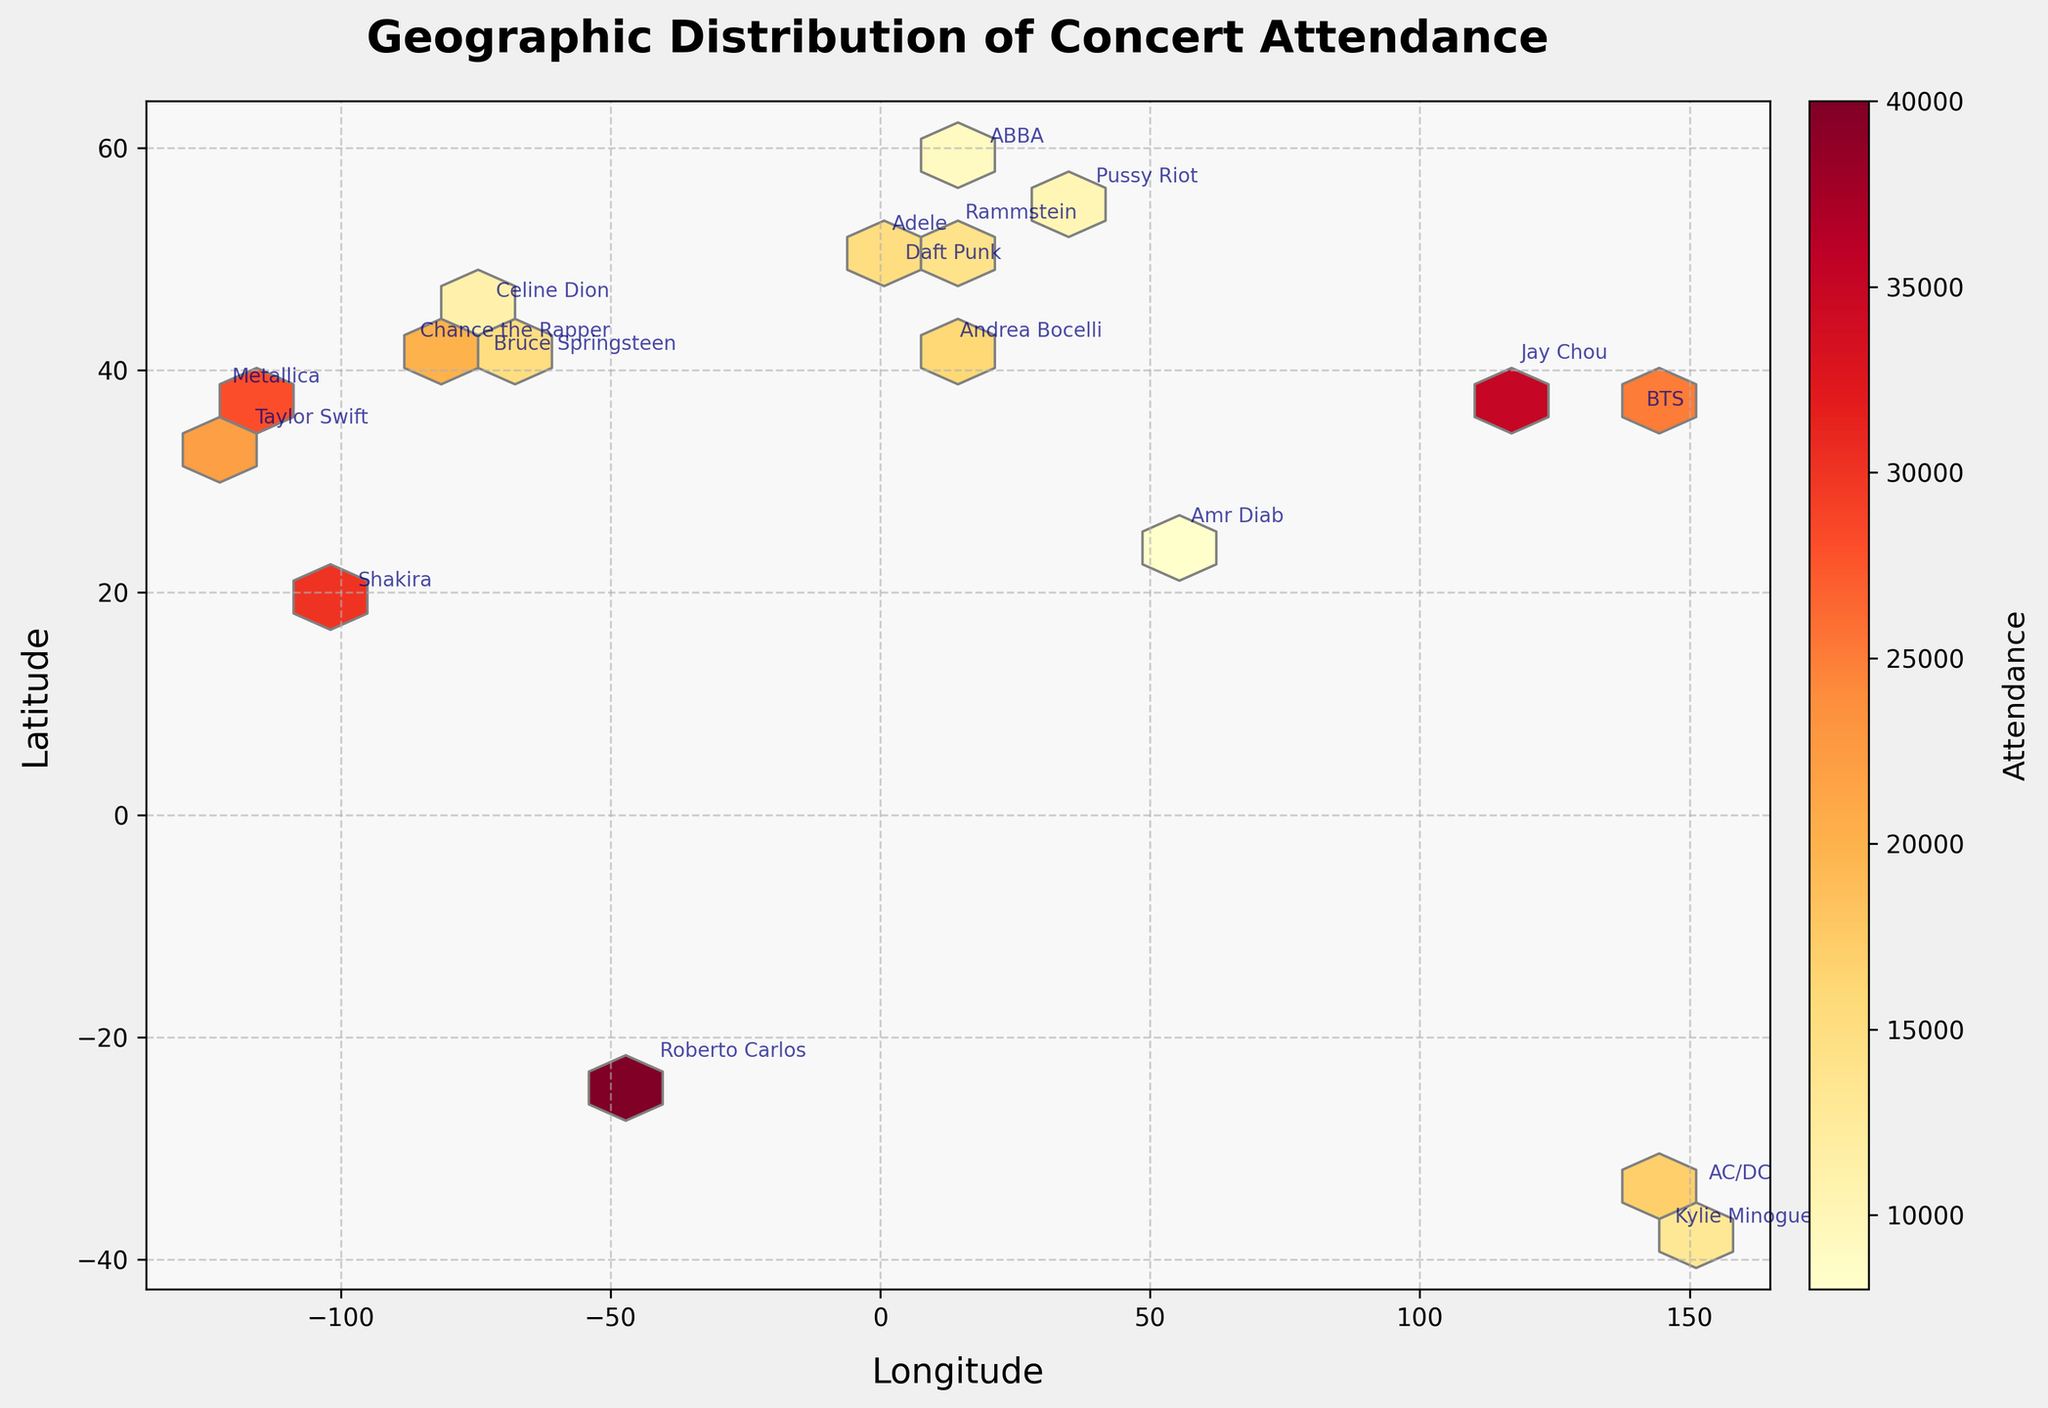What's the geographic distribution of concert attendance for different music artists? The hexbin plot shows a geographic distribution of concert attendance by visualizing data points with latitude on the y-axis and longitude on the x-axis. Each hexagon's color indicates the attendance, where warmer colors represent higher attendance. Artists are annotated at their corresponding concert locations.
Answer: The plot uses various colors to show concert attendance in several global cities for different artists Which artist had the highest concert attendance? To find this, look for the artist annotated at the location with the warmest color hexagon, indicating the highest attendance.
Answer: Jay Chou in Beijing (35,000) Between Taylor Swift and Metallica, who had higher attendance? Compare the color of the hexagons where each artist's concerts are annotated. Metallica had higher attendance.
Answer: Metallica (28,000) What is the title of the plot? The title is at the top of the plot.
Answer: Geographic Distribution of Concert Attendance What are the axes labels? The axes labels are near the respective axes. The x-axis is labeled 'Longitude', and the y-axis is labeled 'Latitude'.
Answer: Longitude (x-axis) and Latitude (y-axis) How does the attendance of Daft Punk compare with that of Rammstein? Compare hexagon colors at the annotated locations for Daft Punk and Rammstein. Daft Punk had higher attendance.
Answer: Daft Punk (12,000) vs. Rammstein (14,000) What is the attendance level for concerts held in South America? Identify the hexagon's color in South America (annotated by Roberto Carlos) and match it to the color bar scale.
Answer: 40,000 by Roberto Carlos in Rio de Janeiro Which artist performed in Russia, and what was the attendance? Locate Russia and see the artist annotation and color-coded attendance.
Answer: Pussy Riot (10,000) Considering the concert distribution, which continent shows the highest number of attendances on average? Identify scored hexagons per continent and average their attendance using the color bar as a reference. China and South America have high values, but Asia (China + Japan) averages higher.
Answer: Asia 